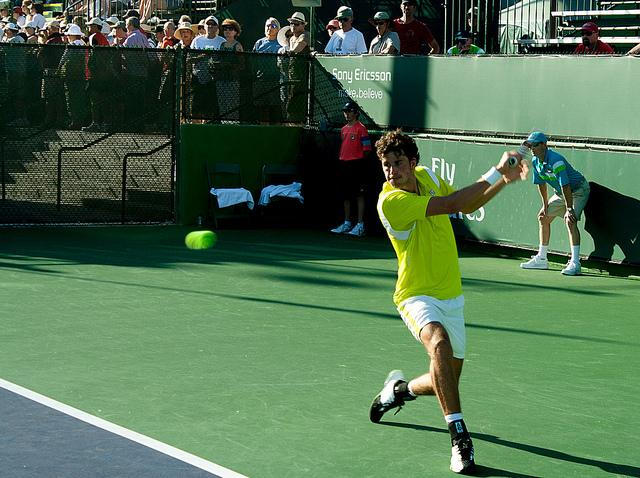Who are the people standing behind the gate?

Choices:
A) coaches
B) travelers
C) spectators
D) jury spectators 